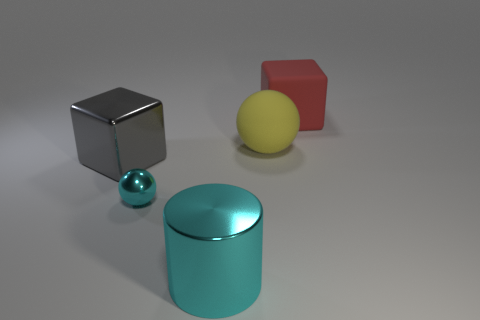Add 1 tiny metallic objects. How many objects exist? 6 Subtract all spheres. How many objects are left? 3 Subtract 0 purple cubes. How many objects are left? 5 Subtract all tiny green spheres. Subtract all tiny cyan balls. How many objects are left? 4 Add 2 gray things. How many gray things are left? 3 Add 1 yellow matte spheres. How many yellow matte spheres exist? 2 